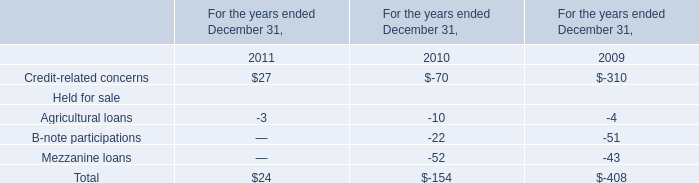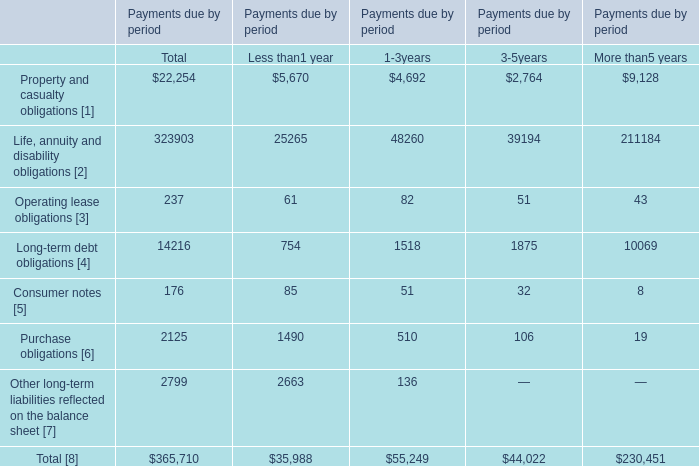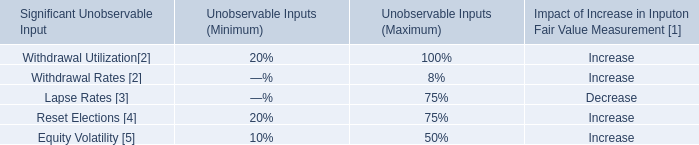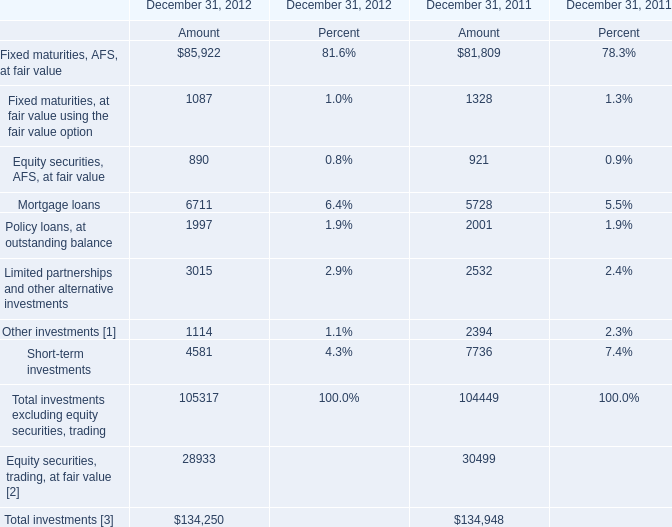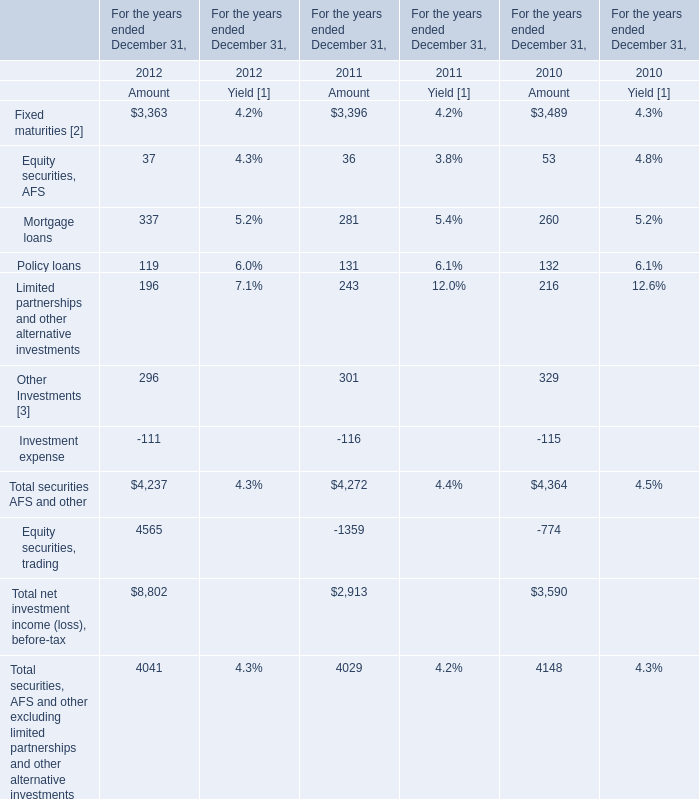Which year does the amount of Total investments rank first? 
Answer: 2011. 